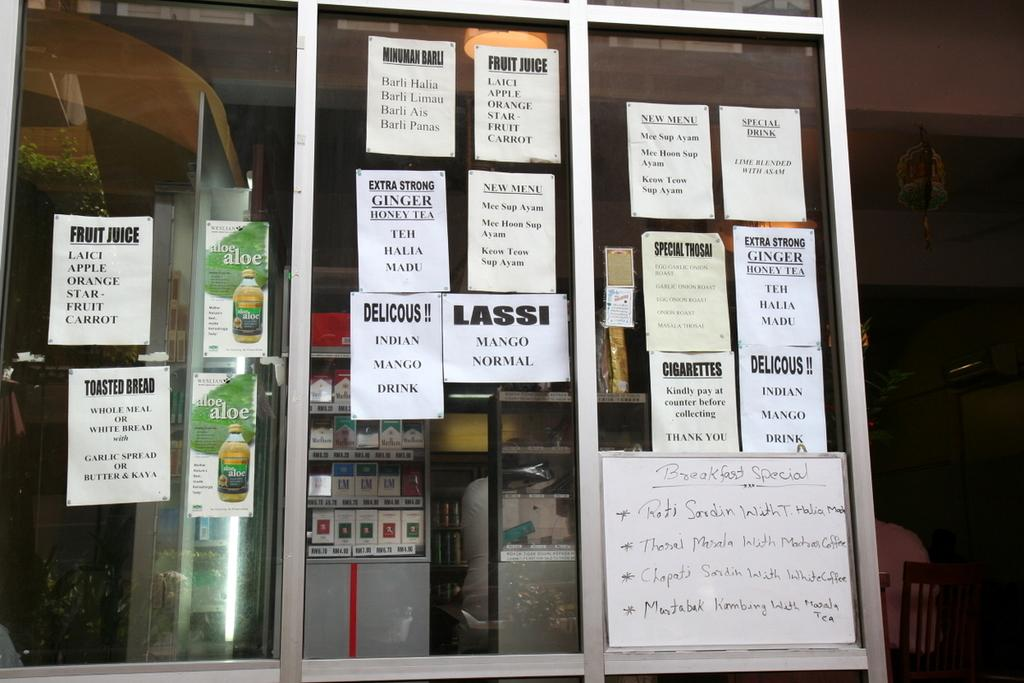<image>
Offer a succinct explanation of the picture presented. Many signs are on a glass window and one says "LASSI". 